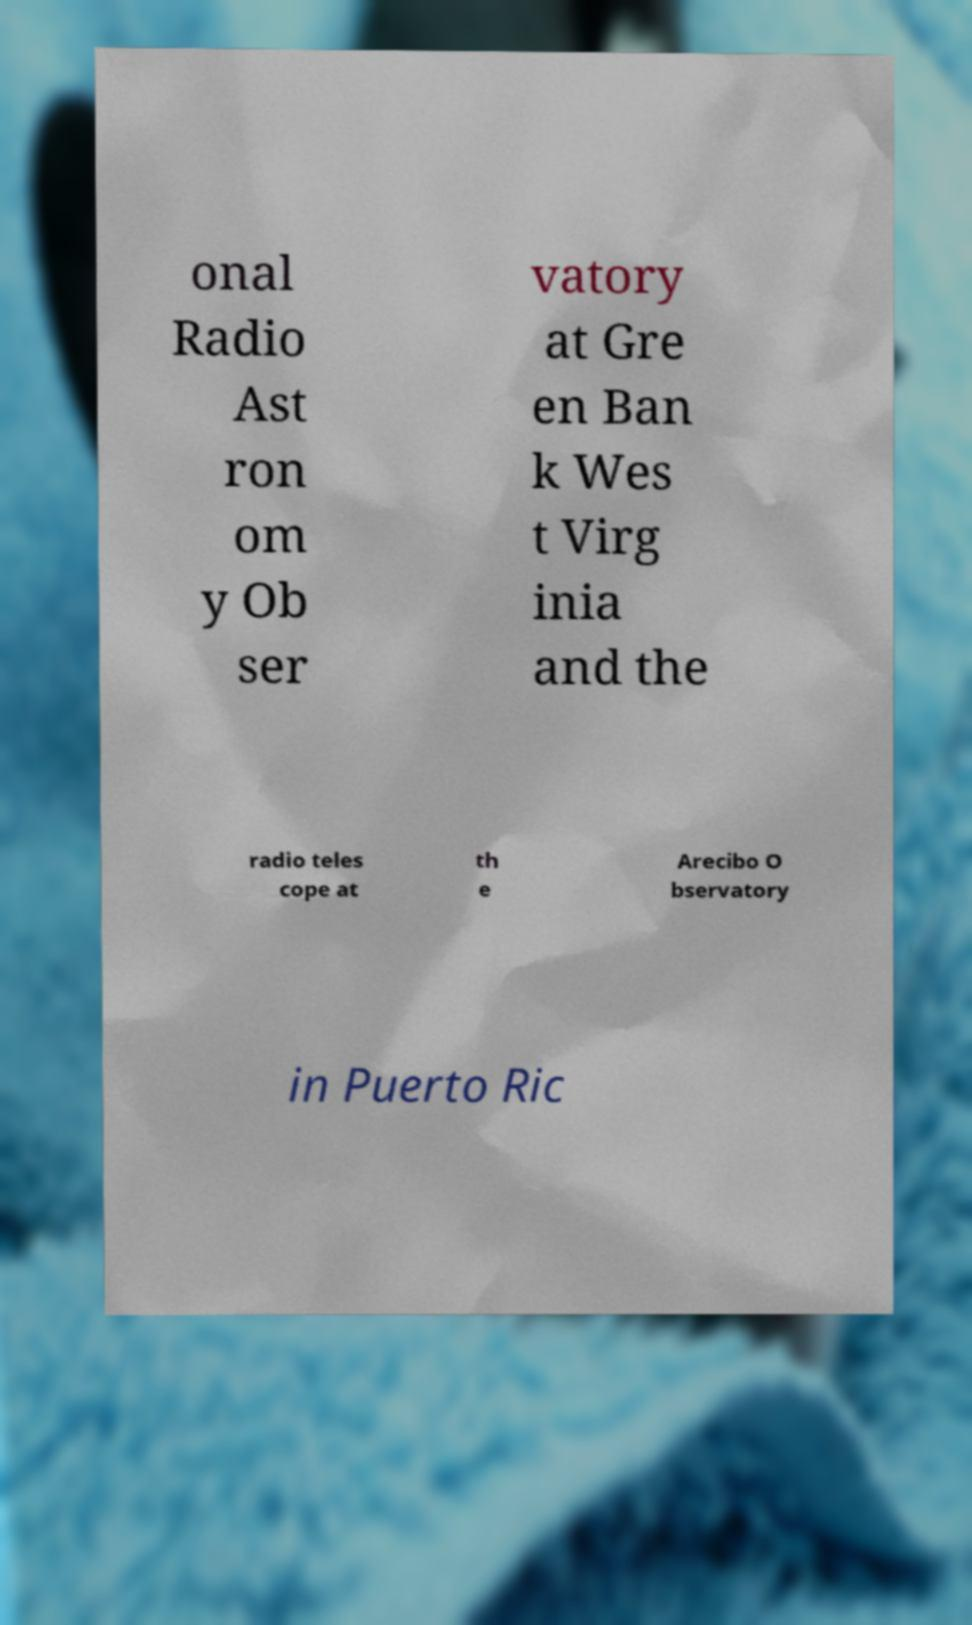Can you read and provide the text displayed in the image?This photo seems to have some interesting text. Can you extract and type it out for me? onal Radio Ast ron om y Ob ser vatory at Gre en Ban k Wes t Virg inia and the radio teles cope at th e Arecibo O bservatory in Puerto Ric 